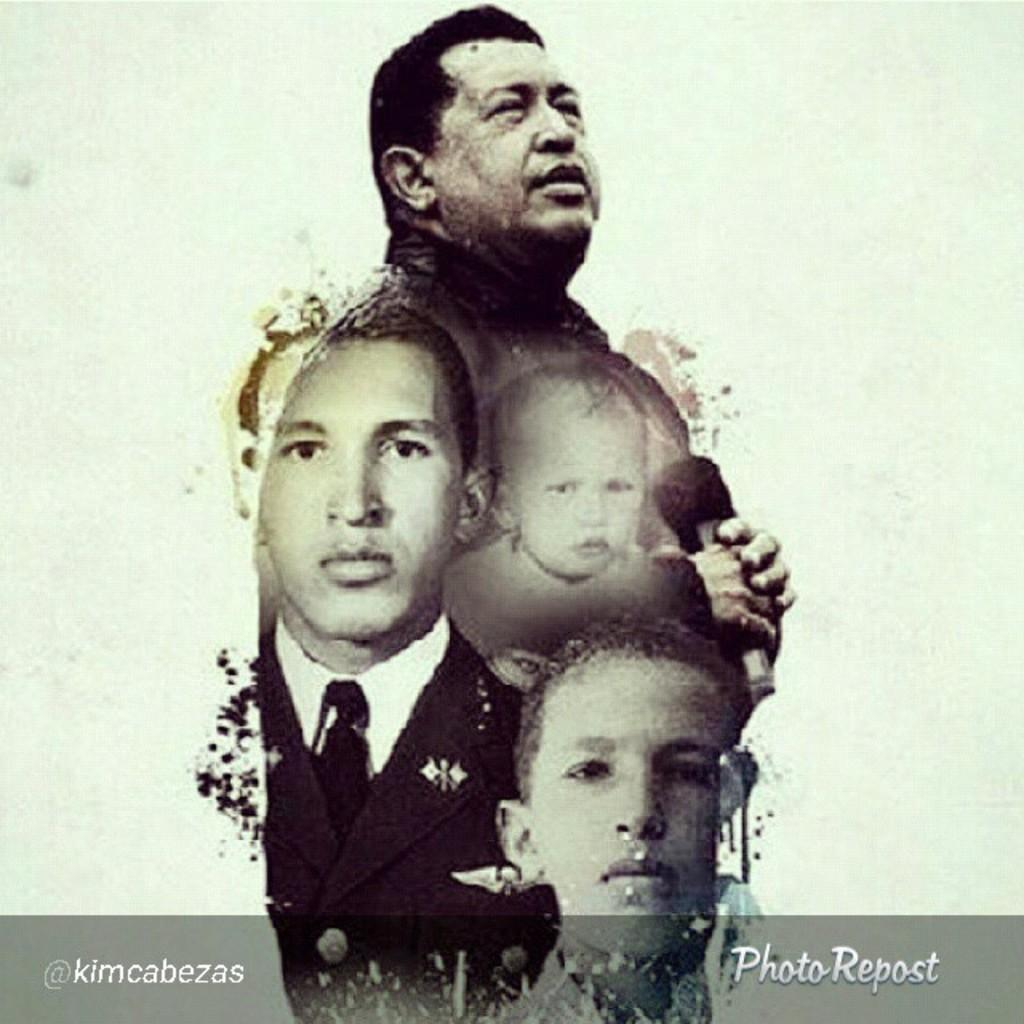What is the main subject of the image? The main subject of the image is a poster. What can be seen on the poster? There are people depicted on the poster, and there is text at the bottom of the poster. What type of cake is being ordered by the people in the image? There is no cake or ordering of cake depicted in the image; it only features a poster with people and text. 